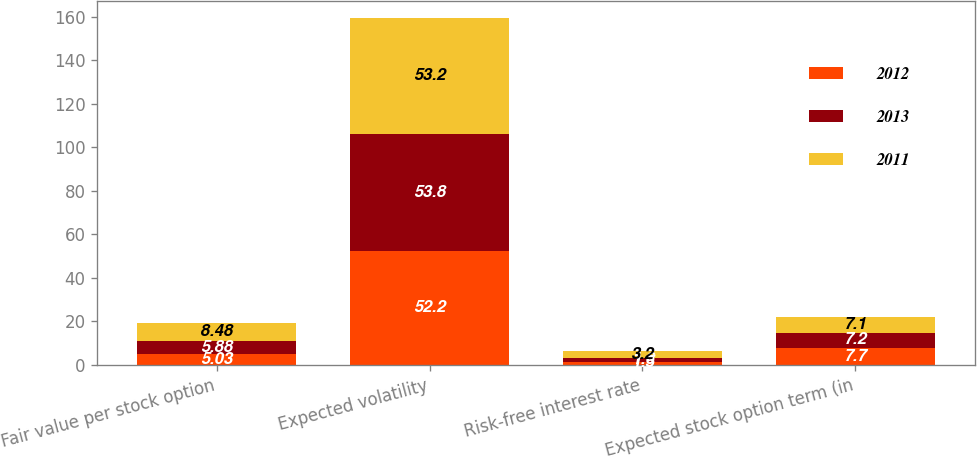Convert chart. <chart><loc_0><loc_0><loc_500><loc_500><stacked_bar_chart><ecel><fcel>Fair value per stock option<fcel>Expected volatility<fcel>Risk-free interest rate<fcel>Expected stock option term (in<nl><fcel>2012<fcel>5.03<fcel>52.2<fcel>1.5<fcel>7.7<nl><fcel>2013<fcel>5.88<fcel>53.8<fcel>1.6<fcel>7.2<nl><fcel>2011<fcel>8.48<fcel>53.2<fcel>3.2<fcel>7.1<nl></chart> 